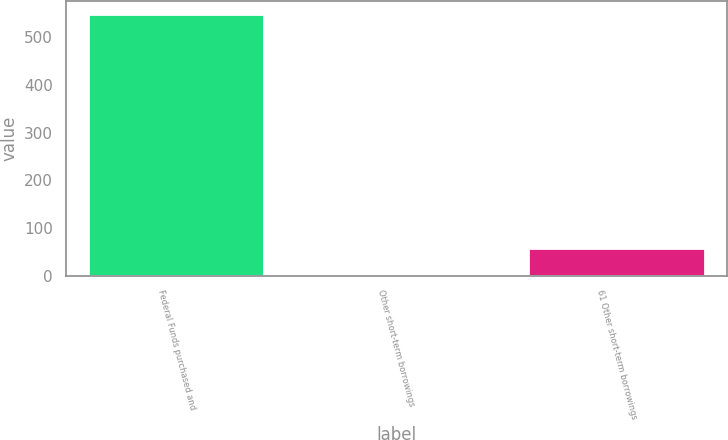Convert chart. <chart><loc_0><loc_0><loc_500><loc_500><bar_chart><fcel>Federal Funds purchased and<fcel>Other short-term borrowings<fcel>61 Other short-term borrowings<nl><fcel>549<fcel>4<fcel>58.5<nl></chart> 